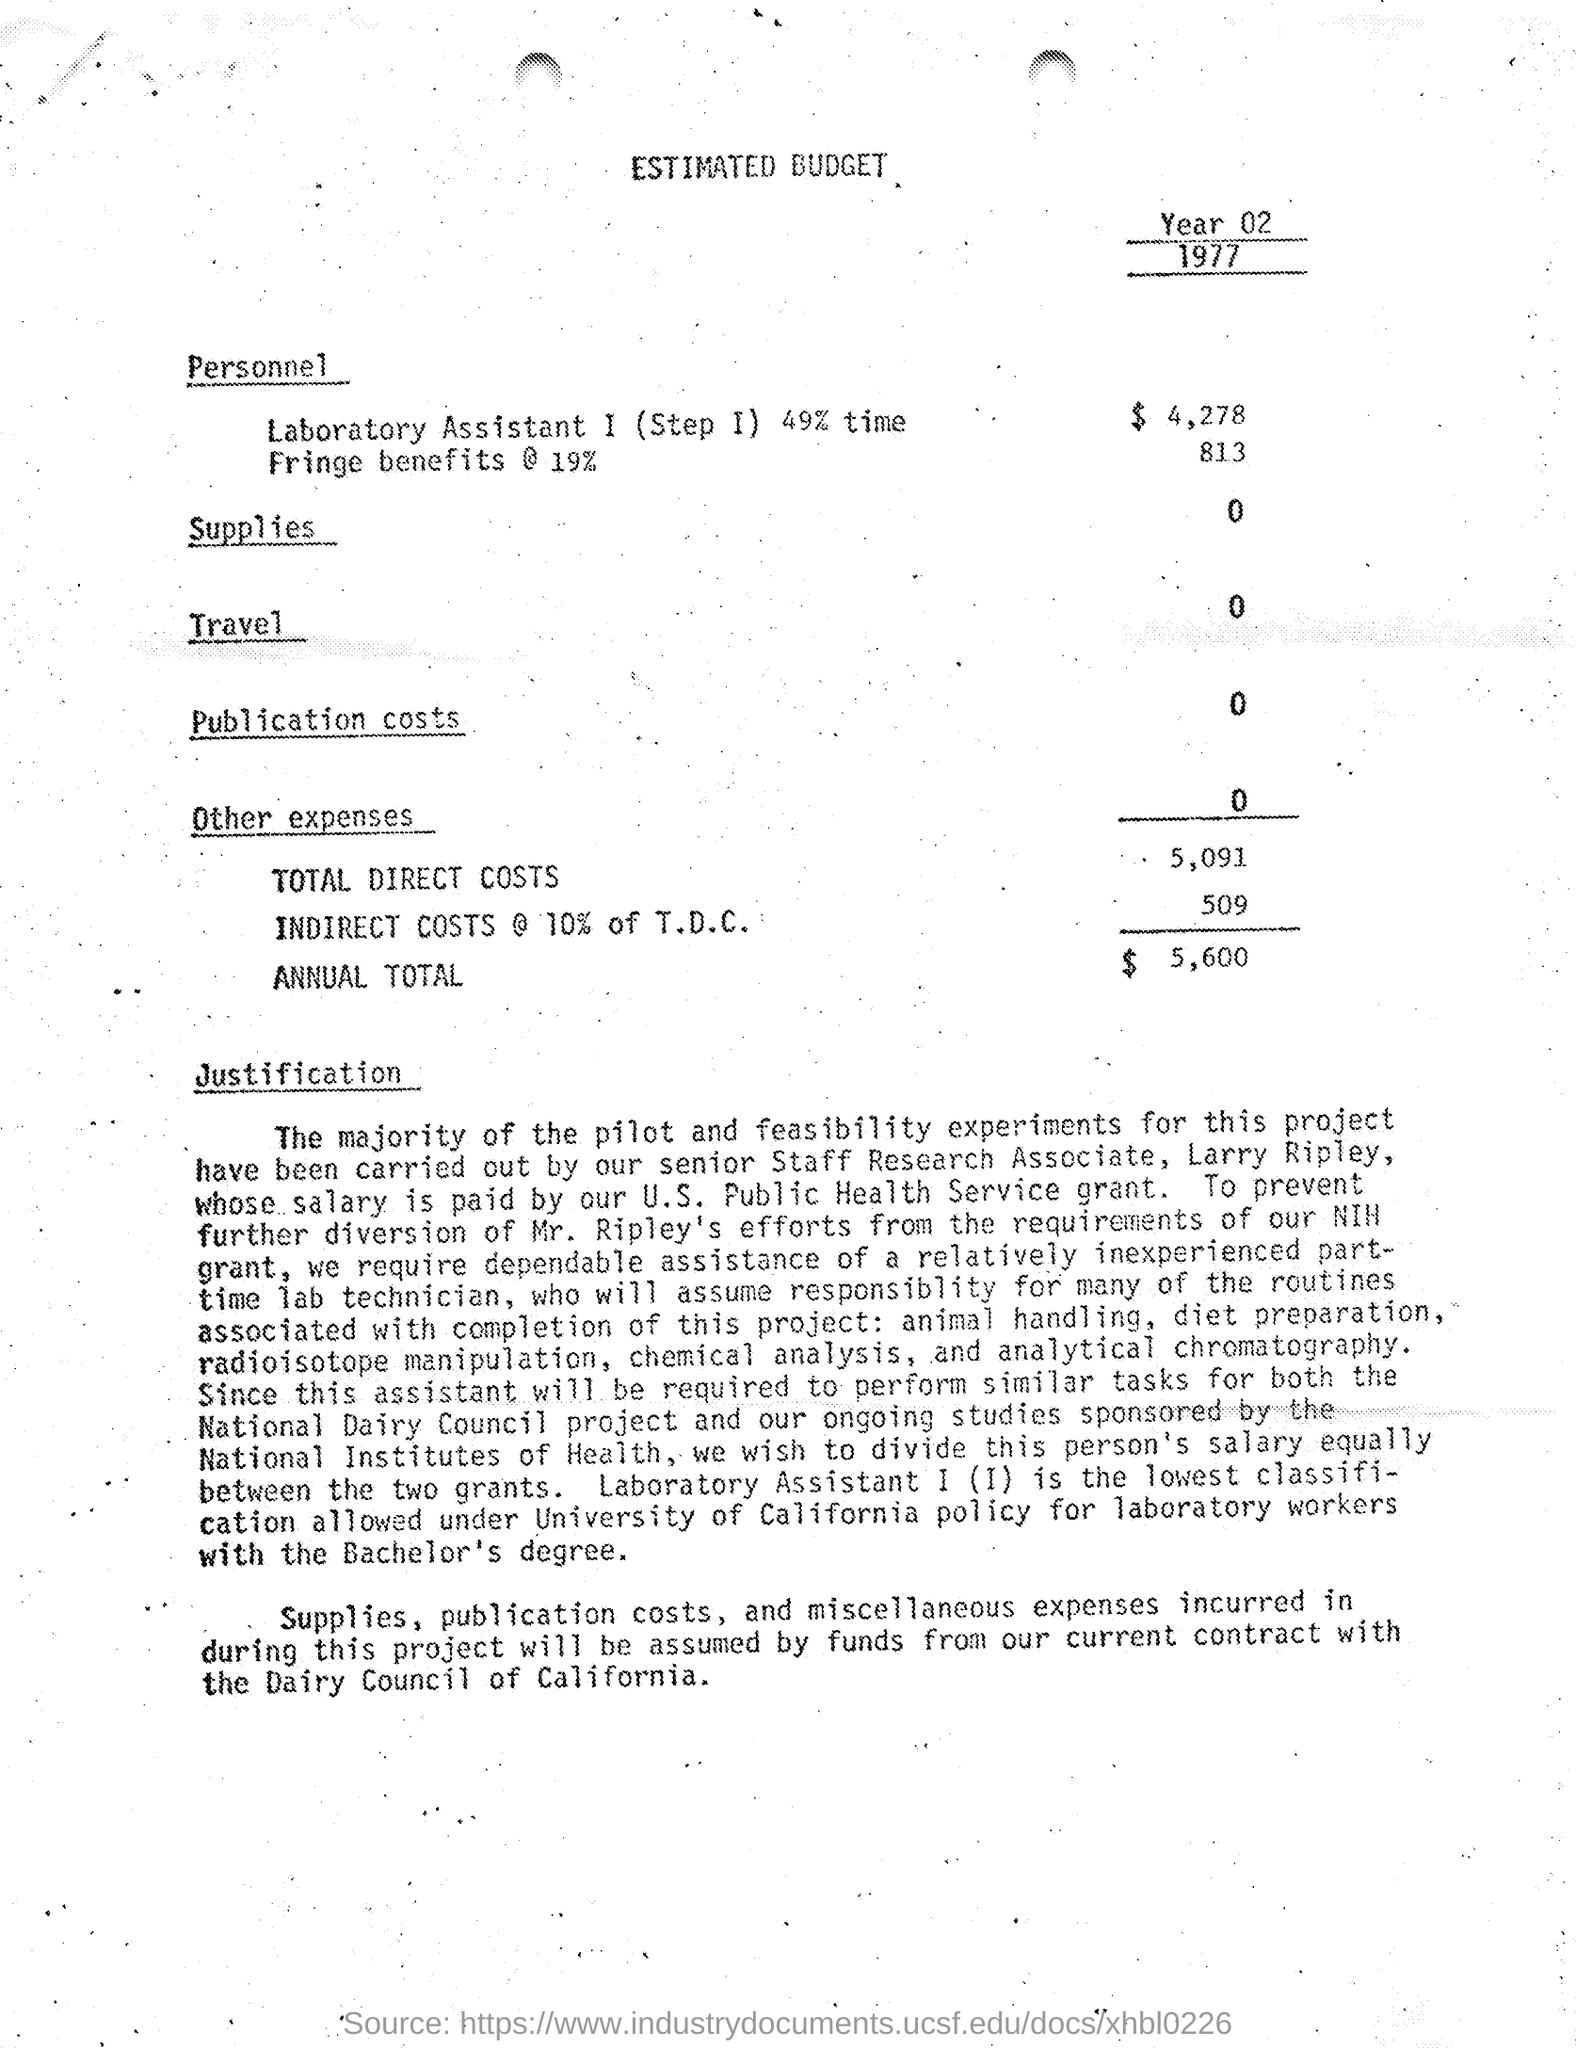What does the justification section mention about the Dairy Council of California? The justification section mentions that 'Supplies, publication costs, and miscellaneous expenses incurred in during this project will be assumed by funds from our current contract with the Dairy Council of California.' This implies that the Dairy Council of California is providing financial support for certain aspects of this project. 